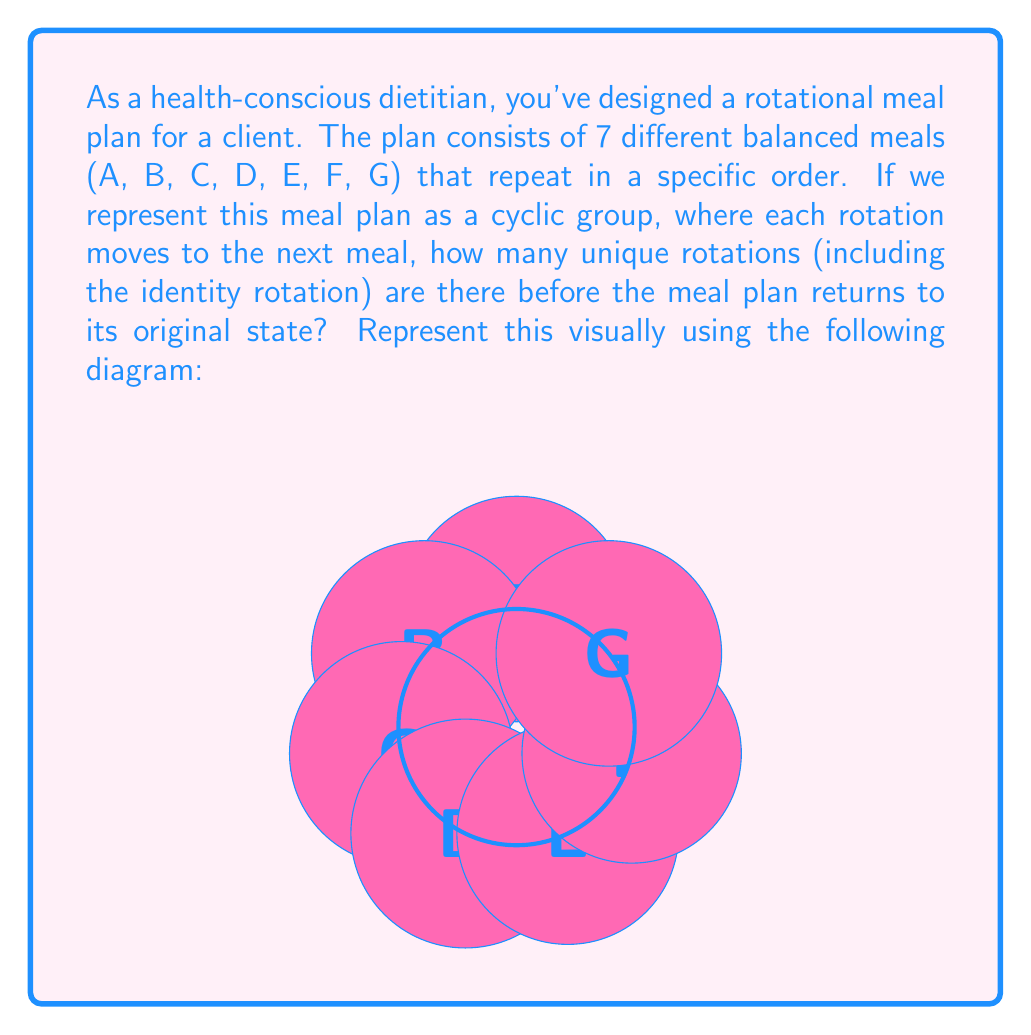Can you answer this question? To solve this problem, we need to understand the properties of cyclic groups and how they relate to our meal plan:

1) In a cyclic group, the number of unique rotations is equal to the order of the group.

2) The order of a cyclic group is equal to the number of elements in the group.

3) In our meal plan, each unique meal (A, B, C, D, E, F, G) represents an element of the group.

4) Counting the meals, we can see that there are 7 elements in our group.

5) Therefore, the cyclic group representing our meal plan has an order of 7.

6) This means there are 7 unique rotations (including the identity rotation where no change occurs) before the meal plan returns to its original state.

7) These rotations can be represented as:
   - Identity (no rotation)
   - Rotate once (A → B, B → C, ..., G → A)
   - Rotate twice (A → C, B → D, ..., G → B)
   - ...
   - Rotate six times (A → G, B → A, ..., G → F)

8) Any further rotation would result in a state we've already seen, thus completing the cycle.

In group theory notation, this cyclic group can be written as $C_7$ or $\mathbb{Z}/7\mathbb{Z}$.
Answer: 7 